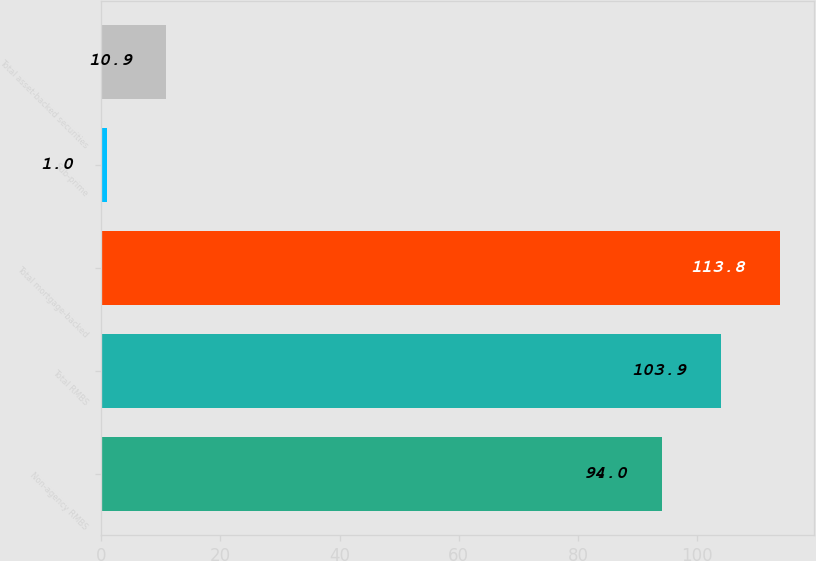Convert chart to OTSL. <chart><loc_0><loc_0><loc_500><loc_500><bar_chart><fcel>Non-agency RMBS<fcel>Total RMBS<fcel>Total mortgage-backed<fcel>Sub-prime<fcel>Total asset-backed securities<nl><fcel>94<fcel>103.9<fcel>113.8<fcel>1<fcel>10.9<nl></chart> 